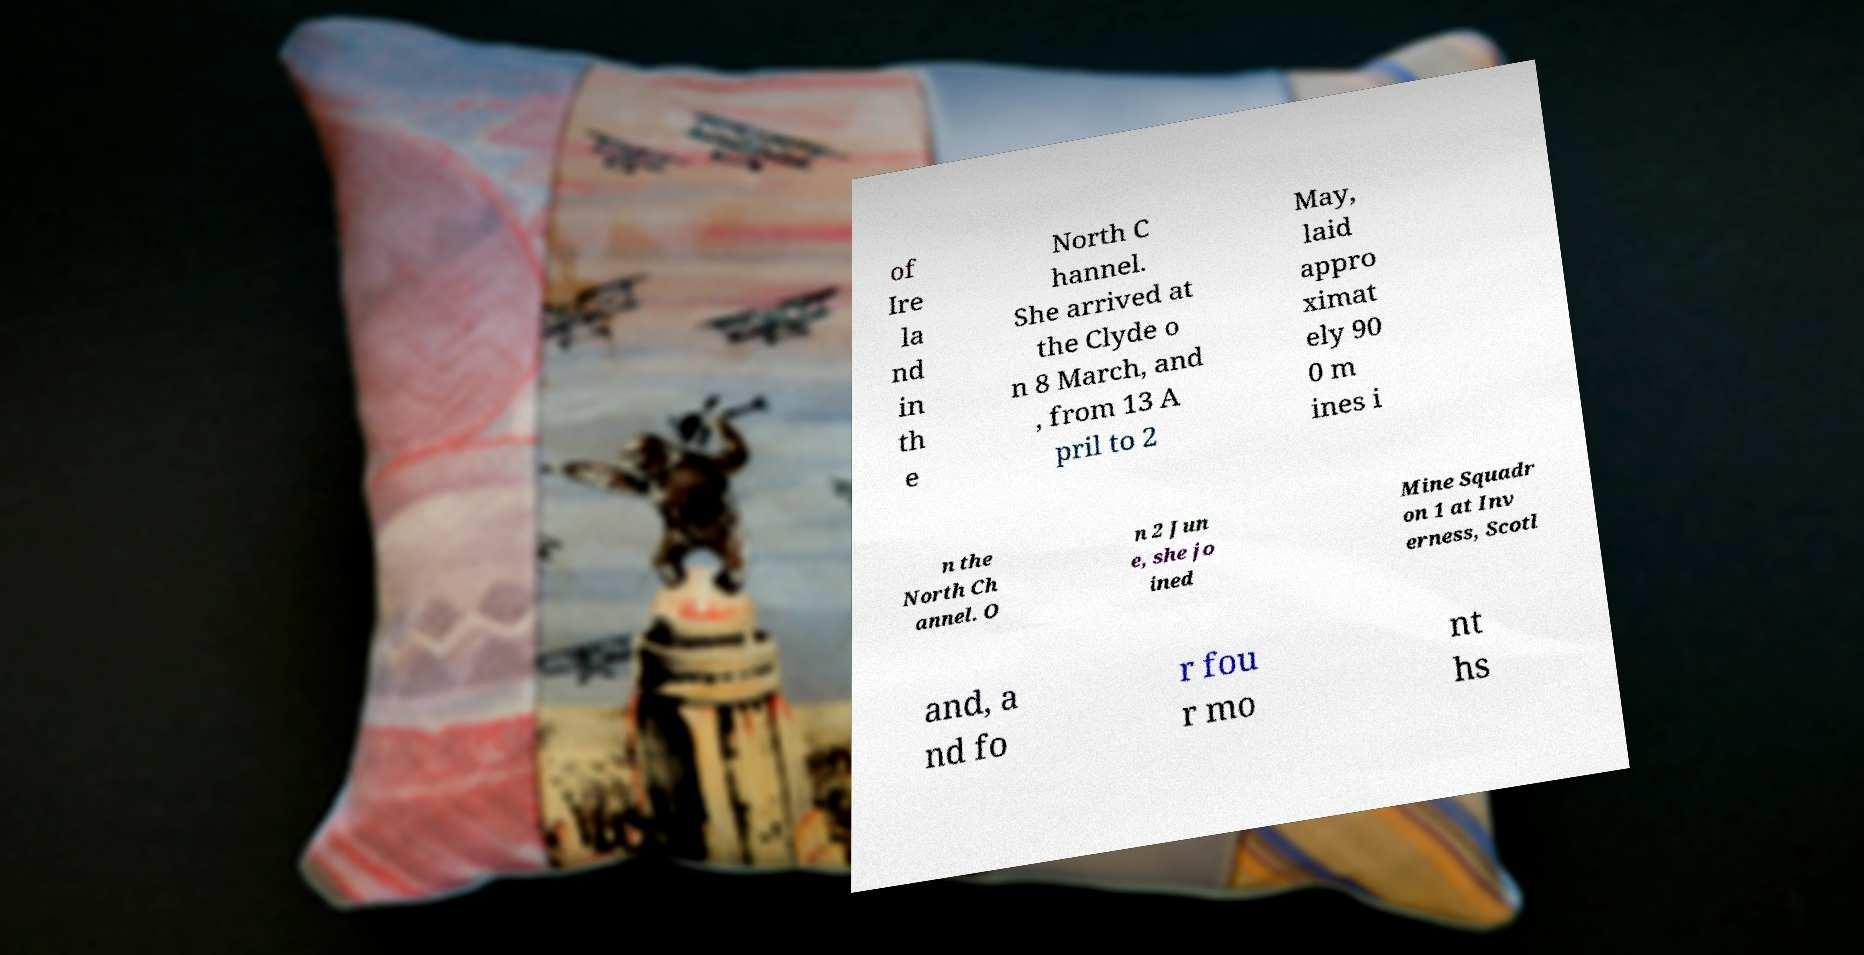Can you read and provide the text displayed in the image?This photo seems to have some interesting text. Can you extract and type it out for me? of Ire la nd in th e North C hannel. She arrived at the Clyde o n 8 March, and , from 13 A pril to 2 May, laid appro ximat ely 90 0 m ines i n the North Ch annel. O n 2 Jun e, she jo ined Mine Squadr on 1 at Inv erness, Scotl and, a nd fo r fou r mo nt hs 